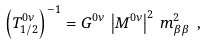Convert formula to latex. <formula><loc_0><loc_0><loc_500><loc_500>\left ( T ^ { 0 \nu } _ { 1 / 2 } \right ) ^ { - 1 } = G ^ { 0 \nu } \, \left | M ^ { 0 \nu } \right | ^ { 2 } \, m _ { \beta \beta } ^ { 2 } \ ,</formula> 